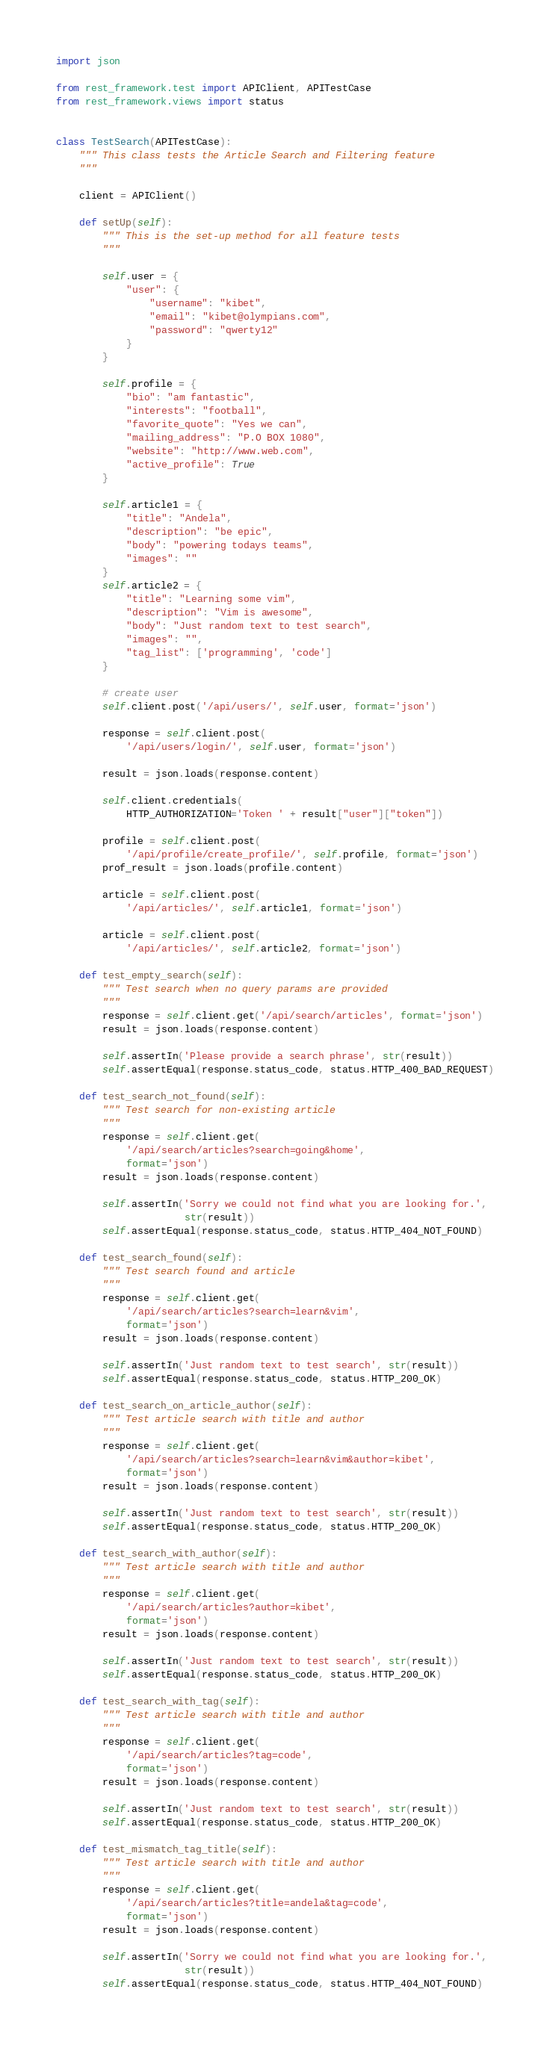Convert code to text. <code><loc_0><loc_0><loc_500><loc_500><_Python_>import json

from rest_framework.test import APIClient, APITestCase
from rest_framework.views import status


class TestSearch(APITestCase):
    """ This class tests the Article Search and Filtering feature
    """

    client = APIClient()

    def setUp(self):
        """ This is the set-up method for all feature tests
        """

        self.user = {
            "user": {
                "username": "kibet",
                "email": "kibet@olympians.com",
                "password": "qwerty12"
            }
        }

        self.profile = {
            "bio": "am fantastic",
            "interests": "football",
            "favorite_quote": "Yes we can",
            "mailing_address": "P.O BOX 1080",
            "website": "http://www.web.com",
            "active_profile": True
        }

        self.article1 = {
            "title": "Andela",
            "description": "be epic",
            "body": "powering todays teams",
            "images": ""
        }
        self.article2 = {
            "title": "Learning some vim",
            "description": "Vim is awesome",
            "body": "Just random text to test search",
            "images": "",
            "tag_list": ['programming', 'code']
        }

        # create user
        self.client.post('/api/users/', self.user, format='json')

        response = self.client.post(
            '/api/users/login/', self.user, format='json')

        result = json.loads(response.content)

        self.client.credentials(
            HTTP_AUTHORIZATION='Token ' + result["user"]["token"])

        profile = self.client.post(
            '/api/profile/create_profile/', self.profile, format='json')
        prof_result = json.loads(profile.content)

        article = self.client.post(
            '/api/articles/', self.article1, format='json')

        article = self.client.post(
            '/api/articles/', self.article2, format='json')

    def test_empty_search(self):
        """ Test search when no query params are provided
        """
        response = self.client.get('/api/search/articles', format='json')
        result = json.loads(response.content)

        self.assertIn('Please provide a search phrase', str(result))
        self.assertEqual(response.status_code, status.HTTP_400_BAD_REQUEST)

    def test_search_not_found(self):
        """ Test search for non-existing article
        """
        response = self.client.get(
            '/api/search/articles?search=going&home',
            format='json')
        result = json.loads(response.content)

        self.assertIn('Sorry we could not find what you are looking for.',
                      str(result))
        self.assertEqual(response.status_code, status.HTTP_404_NOT_FOUND)

    def test_search_found(self):
        """ Test search found and article
        """
        response = self.client.get(
            '/api/search/articles?search=learn&vim',
            format='json')
        result = json.loads(response.content)

        self.assertIn('Just random text to test search', str(result))
        self.assertEqual(response.status_code, status.HTTP_200_OK)

    def test_search_on_article_author(self):
        """ Test article search with title and author
        """
        response = self.client.get(
            '/api/search/articles?search=learn&vim&author=kibet',
            format='json')
        result = json.loads(response.content)

        self.assertIn('Just random text to test search', str(result))
        self.assertEqual(response.status_code, status.HTTP_200_OK)

    def test_search_with_author(self):
        """ Test article search with title and author
        """
        response = self.client.get(
            '/api/search/articles?author=kibet',
            format='json')
        result = json.loads(response.content)

        self.assertIn('Just random text to test search', str(result))
        self.assertEqual(response.status_code, status.HTTP_200_OK)

    def test_search_with_tag(self):
        """ Test article search with title and author
        """
        response = self.client.get(
            '/api/search/articles?tag=code',
            format='json')
        result = json.loads(response.content)

        self.assertIn('Just random text to test search', str(result))
        self.assertEqual(response.status_code, status.HTTP_200_OK)

    def test_mismatch_tag_title(self):
        """ Test article search with title and author
        """
        response = self.client.get(
            '/api/search/articles?title=andela&tag=code',
            format='json')
        result = json.loads(response.content)

        self.assertIn('Sorry we could not find what you are looking for.',
                      str(result))
        self.assertEqual(response.status_code, status.HTTP_404_NOT_FOUND)
</code> 